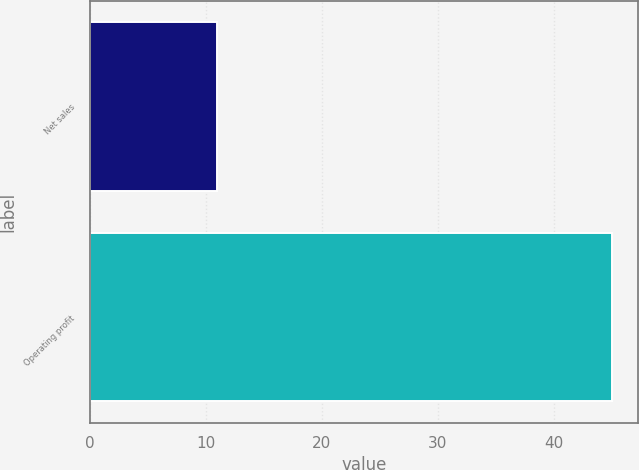<chart> <loc_0><loc_0><loc_500><loc_500><bar_chart><fcel>Net sales<fcel>Operating profit<nl><fcel>11<fcel>45<nl></chart> 